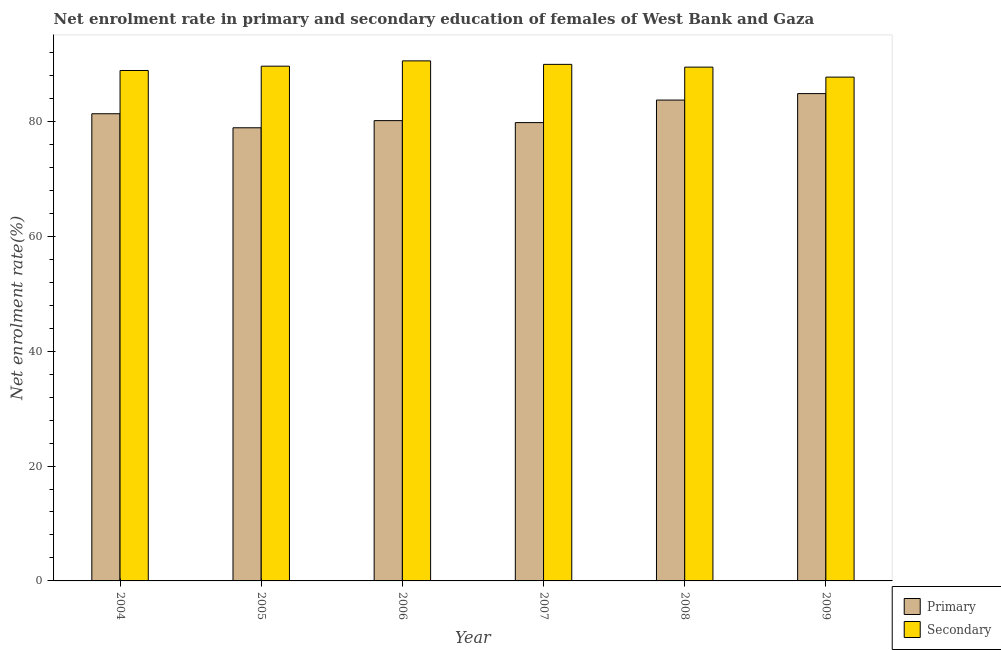How many groups of bars are there?
Give a very brief answer. 6. Are the number of bars per tick equal to the number of legend labels?
Provide a succinct answer. Yes. Are the number of bars on each tick of the X-axis equal?
Ensure brevity in your answer.  Yes. How many bars are there on the 3rd tick from the left?
Make the answer very short. 2. What is the label of the 6th group of bars from the left?
Your response must be concise. 2009. What is the enrollment rate in secondary education in 2008?
Make the answer very short. 89.44. Across all years, what is the maximum enrollment rate in primary education?
Your answer should be very brief. 84.84. Across all years, what is the minimum enrollment rate in secondary education?
Your response must be concise. 87.71. In which year was the enrollment rate in secondary education minimum?
Your answer should be very brief. 2009. What is the total enrollment rate in primary education in the graph?
Make the answer very short. 488.68. What is the difference between the enrollment rate in secondary education in 2004 and that in 2006?
Offer a very short reply. -1.67. What is the difference between the enrollment rate in secondary education in 2006 and the enrollment rate in primary education in 2004?
Offer a very short reply. 1.67. What is the average enrollment rate in secondary education per year?
Your answer should be very brief. 89.35. In how many years, is the enrollment rate in primary education greater than 84 %?
Your response must be concise. 1. What is the ratio of the enrollment rate in secondary education in 2005 to that in 2006?
Give a very brief answer. 0.99. Is the difference between the enrollment rate in secondary education in 2005 and 2007 greater than the difference between the enrollment rate in primary education in 2005 and 2007?
Your answer should be compact. No. What is the difference between the highest and the second highest enrollment rate in secondary education?
Offer a very short reply. 0.61. What is the difference between the highest and the lowest enrollment rate in secondary education?
Provide a succinct answer. 2.83. In how many years, is the enrollment rate in primary education greater than the average enrollment rate in primary education taken over all years?
Your answer should be compact. 2. Is the sum of the enrollment rate in secondary education in 2005 and 2006 greater than the maximum enrollment rate in primary education across all years?
Provide a short and direct response. Yes. What does the 1st bar from the left in 2009 represents?
Keep it short and to the point. Primary. What does the 1st bar from the right in 2007 represents?
Offer a terse response. Secondary. How many bars are there?
Your response must be concise. 12. Are all the bars in the graph horizontal?
Your response must be concise. No. What is the difference between two consecutive major ticks on the Y-axis?
Your response must be concise. 20. Are the values on the major ticks of Y-axis written in scientific E-notation?
Provide a succinct answer. No. Does the graph contain any zero values?
Offer a terse response. No. Does the graph contain grids?
Offer a very short reply. No. How many legend labels are there?
Give a very brief answer. 2. What is the title of the graph?
Provide a short and direct response. Net enrolment rate in primary and secondary education of females of West Bank and Gaza. Does "Methane emissions" appear as one of the legend labels in the graph?
Ensure brevity in your answer.  No. What is the label or title of the X-axis?
Provide a short and direct response. Year. What is the label or title of the Y-axis?
Your answer should be compact. Net enrolment rate(%). What is the Net enrolment rate(%) of Primary in 2004?
Give a very brief answer. 81.33. What is the Net enrolment rate(%) of Secondary in 2004?
Your answer should be very brief. 88.86. What is the Net enrolment rate(%) of Primary in 2005?
Your response must be concise. 78.89. What is the Net enrolment rate(%) in Secondary in 2005?
Give a very brief answer. 89.61. What is the Net enrolment rate(%) of Primary in 2006?
Give a very brief answer. 80.13. What is the Net enrolment rate(%) in Secondary in 2006?
Keep it short and to the point. 90.53. What is the Net enrolment rate(%) in Primary in 2007?
Keep it short and to the point. 79.79. What is the Net enrolment rate(%) in Secondary in 2007?
Your response must be concise. 89.92. What is the Net enrolment rate(%) of Primary in 2008?
Your answer should be very brief. 83.71. What is the Net enrolment rate(%) of Secondary in 2008?
Provide a short and direct response. 89.44. What is the Net enrolment rate(%) in Primary in 2009?
Provide a succinct answer. 84.84. What is the Net enrolment rate(%) of Secondary in 2009?
Offer a very short reply. 87.71. Across all years, what is the maximum Net enrolment rate(%) of Primary?
Your answer should be compact. 84.84. Across all years, what is the maximum Net enrolment rate(%) of Secondary?
Give a very brief answer. 90.53. Across all years, what is the minimum Net enrolment rate(%) in Primary?
Give a very brief answer. 78.89. Across all years, what is the minimum Net enrolment rate(%) in Secondary?
Make the answer very short. 87.71. What is the total Net enrolment rate(%) in Primary in the graph?
Keep it short and to the point. 488.68. What is the total Net enrolment rate(%) of Secondary in the graph?
Give a very brief answer. 536.07. What is the difference between the Net enrolment rate(%) of Primary in 2004 and that in 2005?
Offer a very short reply. 2.44. What is the difference between the Net enrolment rate(%) in Secondary in 2004 and that in 2005?
Provide a succinct answer. -0.75. What is the difference between the Net enrolment rate(%) in Primary in 2004 and that in 2006?
Make the answer very short. 1.2. What is the difference between the Net enrolment rate(%) in Secondary in 2004 and that in 2006?
Give a very brief answer. -1.67. What is the difference between the Net enrolment rate(%) in Primary in 2004 and that in 2007?
Offer a terse response. 1.54. What is the difference between the Net enrolment rate(%) of Secondary in 2004 and that in 2007?
Your answer should be very brief. -1.07. What is the difference between the Net enrolment rate(%) of Primary in 2004 and that in 2008?
Give a very brief answer. -2.38. What is the difference between the Net enrolment rate(%) of Secondary in 2004 and that in 2008?
Provide a short and direct response. -0.58. What is the difference between the Net enrolment rate(%) of Primary in 2004 and that in 2009?
Your answer should be very brief. -3.51. What is the difference between the Net enrolment rate(%) in Secondary in 2004 and that in 2009?
Keep it short and to the point. 1.15. What is the difference between the Net enrolment rate(%) of Primary in 2005 and that in 2006?
Your response must be concise. -1.24. What is the difference between the Net enrolment rate(%) of Secondary in 2005 and that in 2006?
Keep it short and to the point. -0.92. What is the difference between the Net enrolment rate(%) of Primary in 2005 and that in 2007?
Offer a terse response. -0.9. What is the difference between the Net enrolment rate(%) in Secondary in 2005 and that in 2007?
Your answer should be compact. -0.32. What is the difference between the Net enrolment rate(%) in Primary in 2005 and that in 2008?
Your answer should be compact. -4.82. What is the difference between the Net enrolment rate(%) of Secondary in 2005 and that in 2008?
Give a very brief answer. 0.16. What is the difference between the Net enrolment rate(%) of Primary in 2005 and that in 2009?
Provide a short and direct response. -5.95. What is the difference between the Net enrolment rate(%) of Secondary in 2005 and that in 2009?
Provide a succinct answer. 1.9. What is the difference between the Net enrolment rate(%) in Primary in 2006 and that in 2007?
Your response must be concise. 0.34. What is the difference between the Net enrolment rate(%) in Secondary in 2006 and that in 2007?
Provide a short and direct response. 0.61. What is the difference between the Net enrolment rate(%) of Primary in 2006 and that in 2008?
Give a very brief answer. -3.58. What is the difference between the Net enrolment rate(%) in Secondary in 2006 and that in 2008?
Your response must be concise. 1.09. What is the difference between the Net enrolment rate(%) of Primary in 2006 and that in 2009?
Provide a short and direct response. -4.71. What is the difference between the Net enrolment rate(%) of Secondary in 2006 and that in 2009?
Offer a terse response. 2.83. What is the difference between the Net enrolment rate(%) in Primary in 2007 and that in 2008?
Offer a very short reply. -3.92. What is the difference between the Net enrolment rate(%) in Secondary in 2007 and that in 2008?
Offer a terse response. 0.48. What is the difference between the Net enrolment rate(%) of Primary in 2007 and that in 2009?
Give a very brief answer. -5.05. What is the difference between the Net enrolment rate(%) of Secondary in 2007 and that in 2009?
Your answer should be very brief. 2.22. What is the difference between the Net enrolment rate(%) of Primary in 2008 and that in 2009?
Offer a terse response. -1.13. What is the difference between the Net enrolment rate(%) in Secondary in 2008 and that in 2009?
Your response must be concise. 1.74. What is the difference between the Net enrolment rate(%) of Primary in 2004 and the Net enrolment rate(%) of Secondary in 2005?
Make the answer very short. -8.28. What is the difference between the Net enrolment rate(%) of Primary in 2004 and the Net enrolment rate(%) of Secondary in 2006?
Make the answer very short. -9.2. What is the difference between the Net enrolment rate(%) of Primary in 2004 and the Net enrolment rate(%) of Secondary in 2007?
Offer a very short reply. -8.6. What is the difference between the Net enrolment rate(%) in Primary in 2004 and the Net enrolment rate(%) in Secondary in 2008?
Your response must be concise. -8.11. What is the difference between the Net enrolment rate(%) in Primary in 2004 and the Net enrolment rate(%) in Secondary in 2009?
Keep it short and to the point. -6.38. What is the difference between the Net enrolment rate(%) of Primary in 2005 and the Net enrolment rate(%) of Secondary in 2006?
Keep it short and to the point. -11.65. What is the difference between the Net enrolment rate(%) in Primary in 2005 and the Net enrolment rate(%) in Secondary in 2007?
Provide a short and direct response. -11.04. What is the difference between the Net enrolment rate(%) of Primary in 2005 and the Net enrolment rate(%) of Secondary in 2008?
Provide a short and direct response. -10.56. What is the difference between the Net enrolment rate(%) in Primary in 2005 and the Net enrolment rate(%) in Secondary in 2009?
Ensure brevity in your answer.  -8.82. What is the difference between the Net enrolment rate(%) in Primary in 2006 and the Net enrolment rate(%) in Secondary in 2007?
Keep it short and to the point. -9.79. What is the difference between the Net enrolment rate(%) of Primary in 2006 and the Net enrolment rate(%) of Secondary in 2008?
Give a very brief answer. -9.31. What is the difference between the Net enrolment rate(%) of Primary in 2006 and the Net enrolment rate(%) of Secondary in 2009?
Your response must be concise. -7.58. What is the difference between the Net enrolment rate(%) in Primary in 2007 and the Net enrolment rate(%) in Secondary in 2008?
Your response must be concise. -9.66. What is the difference between the Net enrolment rate(%) of Primary in 2007 and the Net enrolment rate(%) of Secondary in 2009?
Offer a very short reply. -7.92. What is the difference between the Net enrolment rate(%) of Primary in 2008 and the Net enrolment rate(%) of Secondary in 2009?
Your response must be concise. -4. What is the average Net enrolment rate(%) in Primary per year?
Provide a short and direct response. 81.45. What is the average Net enrolment rate(%) of Secondary per year?
Your answer should be compact. 89.35. In the year 2004, what is the difference between the Net enrolment rate(%) in Primary and Net enrolment rate(%) in Secondary?
Keep it short and to the point. -7.53. In the year 2005, what is the difference between the Net enrolment rate(%) of Primary and Net enrolment rate(%) of Secondary?
Your response must be concise. -10.72. In the year 2006, what is the difference between the Net enrolment rate(%) in Primary and Net enrolment rate(%) in Secondary?
Provide a short and direct response. -10.4. In the year 2007, what is the difference between the Net enrolment rate(%) of Primary and Net enrolment rate(%) of Secondary?
Give a very brief answer. -10.14. In the year 2008, what is the difference between the Net enrolment rate(%) in Primary and Net enrolment rate(%) in Secondary?
Provide a succinct answer. -5.74. In the year 2009, what is the difference between the Net enrolment rate(%) of Primary and Net enrolment rate(%) of Secondary?
Provide a short and direct response. -2.87. What is the ratio of the Net enrolment rate(%) of Primary in 2004 to that in 2005?
Provide a short and direct response. 1.03. What is the ratio of the Net enrolment rate(%) in Secondary in 2004 to that in 2005?
Your answer should be very brief. 0.99. What is the ratio of the Net enrolment rate(%) of Primary in 2004 to that in 2006?
Your answer should be very brief. 1.01. What is the ratio of the Net enrolment rate(%) of Secondary in 2004 to that in 2006?
Give a very brief answer. 0.98. What is the ratio of the Net enrolment rate(%) in Primary in 2004 to that in 2007?
Make the answer very short. 1.02. What is the ratio of the Net enrolment rate(%) in Primary in 2004 to that in 2008?
Offer a very short reply. 0.97. What is the ratio of the Net enrolment rate(%) of Secondary in 2004 to that in 2008?
Your answer should be compact. 0.99. What is the ratio of the Net enrolment rate(%) of Primary in 2004 to that in 2009?
Ensure brevity in your answer.  0.96. What is the ratio of the Net enrolment rate(%) in Secondary in 2004 to that in 2009?
Your answer should be compact. 1.01. What is the ratio of the Net enrolment rate(%) of Primary in 2005 to that in 2006?
Provide a succinct answer. 0.98. What is the ratio of the Net enrolment rate(%) of Primary in 2005 to that in 2007?
Ensure brevity in your answer.  0.99. What is the ratio of the Net enrolment rate(%) in Secondary in 2005 to that in 2007?
Your response must be concise. 1. What is the ratio of the Net enrolment rate(%) in Primary in 2005 to that in 2008?
Make the answer very short. 0.94. What is the ratio of the Net enrolment rate(%) of Secondary in 2005 to that in 2008?
Ensure brevity in your answer.  1. What is the ratio of the Net enrolment rate(%) in Primary in 2005 to that in 2009?
Make the answer very short. 0.93. What is the ratio of the Net enrolment rate(%) in Secondary in 2005 to that in 2009?
Make the answer very short. 1.02. What is the ratio of the Net enrolment rate(%) of Primary in 2006 to that in 2007?
Ensure brevity in your answer.  1. What is the ratio of the Net enrolment rate(%) in Secondary in 2006 to that in 2007?
Your answer should be very brief. 1.01. What is the ratio of the Net enrolment rate(%) of Primary in 2006 to that in 2008?
Offer a very short reply. 0.96. What is the ratio of the Net enrolment rate(%) in Secondary in 2006 to that in 2008?
Your answer should be compact. 1.01. What is the ratio of the Net enrolment rate(%) in Primary in 2006 to that in 2009?
Ensure brevity in your answer.  0.94. What is the ratio of the Net enrolment rate(%) in Secondary in 2006 to that in 2009?
Provide a short and direct response. 1.03. What is the ratio of the Net enrolment rate(%) of Primary in 2007 to that in 2008?
Your response must be concise. 0.95. What is the ratio of the Net enrolment rate(%) of Secondary in 2007 to that in 2008?
Provide a short and direct response. 1.01. What is the ratio of the Net enrolment rate(%) of Primary in 2007 to that in 2009?
Give a very brief answer. 0.94. What is the ratio of the Net enrolment rate(%) of Secondary in 2007 to that in 2009?
Offer a very short reply. 1.03. What is the ratio of the Net enrolment rate(%) in Primary in 2008 to that in 2009?
Provide a succinct answer. 0.99. What is the ratio of the Net enrolment rate(%) of Secondary in 2008 to that in 2009?
Give a very brief answer. 1.02. What is the difference between the highest and the second highest Net enrolment rate(%) of Primary?
Ensure brevity in your answer.  1.13. What is the difference between the highest and the second highest Net enrolment rate(%) in Secondary?
Your answer should be very brief. 0.61. What is the difference between the highest and the lowest Net enrolment rate(%) in Primary?
Your answer should be very brief. 5.95. What is the difference between the highest and the lowest Net enrolment rate(%) of Secondary?
Ensure brevity in your answer.  2.83. 